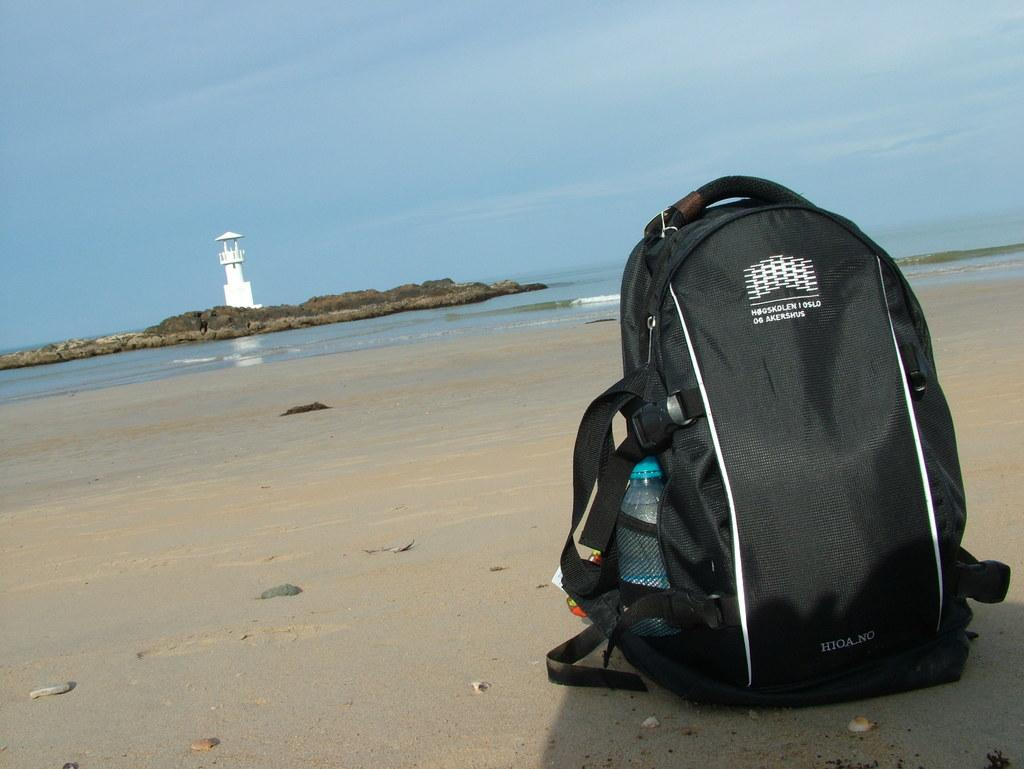<image>
Share a concise interpretation of the image provided. A black backpack with white text on it including Oslo sits in the sand away from the water. 